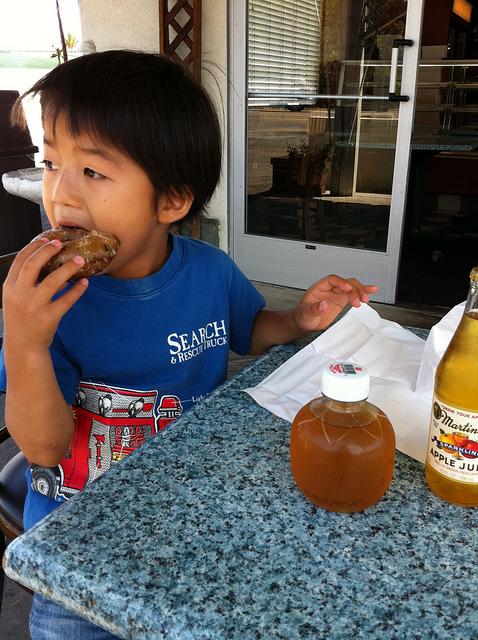How many different drinks are there?
Concise answer only. 2. What is in the bottles?
Be succinct. Juice. What is the boy eating?
Quick response, please. Donut. 